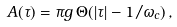Convert formula to latex. <formula><loc_0><loc_0><loc_500><loc_500>A ( \tau ) = \pi g \, \Theta ( | \tau | - 1 / \omega _ { c } ) \, ,</formula> 